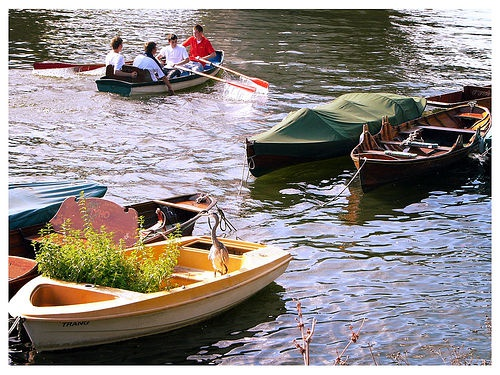Describe the objects in this image and their specific colors. I can see boat in white, olive, black, and brown tones, boat in white, brown, black, and olive tones, boat in white, black, gray, and darkgray tones, potted plant in white, olive, black, and brown tones, and boat in white, black, maroon, lightgray, and gray tones in this image. 